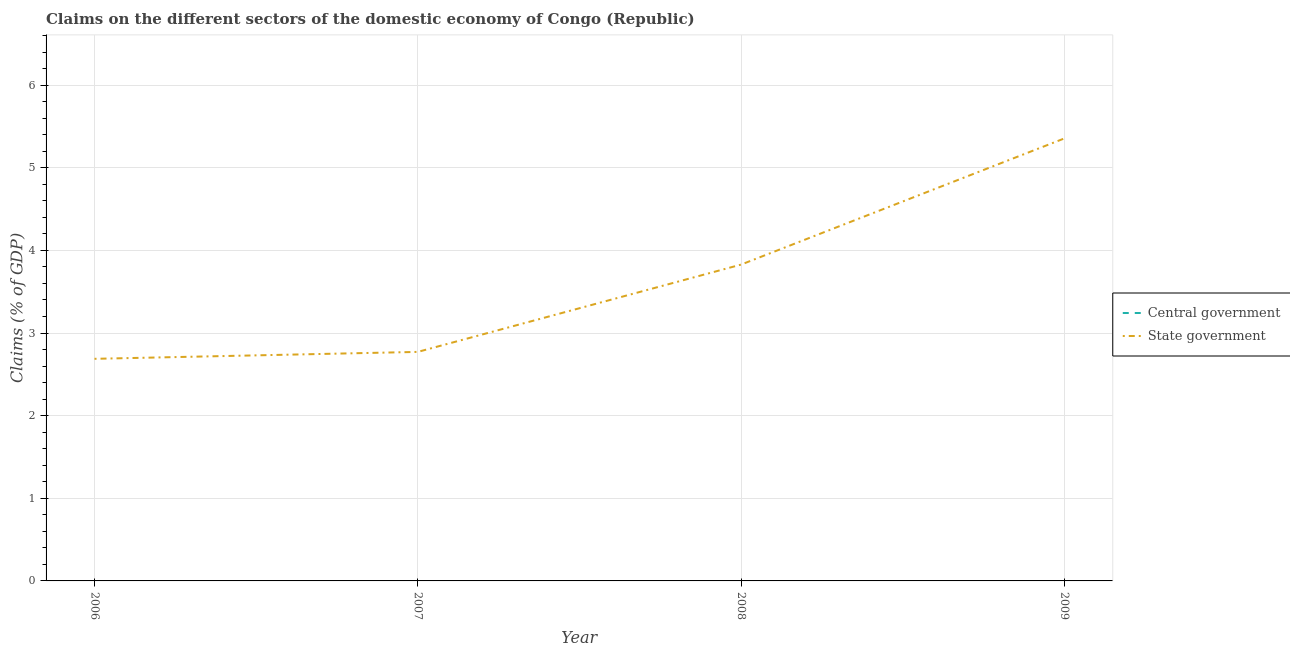How many different coloured lines are there?
Ensure brevity in your answer.  1. Does the line corresponding to claims on central government intersect with the line corresponding to claims on state government?
Offer a very short reply. No. Is the number of lines equal to the number of legend labels?
Provide a succinct answer. No. Across all years, what is the maximum claims on state government?
Provide a short and direct response. 5.35. Across all years, what is the minimum claims on state government?
Ensure brevity in your answer.  2.69. What is the total claims on state government in the graph?
Offer a very short reply. 14.64. What is the difference between the claims on state government in 2006 and that in 2009?
Your answer should be compact. -2.67. What is the difference between the claims on central government in 2009 and the claims on state government in 2007?
Your answer should be compact. -2.77. What is the average claims on central government per year?
Provide a short and direct response. 0. What is the ratio of the claims on state government in 2006 to that in 2008?
Your response must be concise. 0.7. What is the difference between the highest and the second highest claims on state government?
Offer a very short reply. 1.53. What is the difference between the highest and the lowest claims on state government?
Offer a very short reply. 2.67. In how many years, is the claims on central government greater than the average claims on central government taken over all years?
Your answer should be compact. 0. Is the sum of the claims on state government in 2007 and 2009 greater than the maximum claims on central government across all years?
Provide a succinct answer. Yes. Does the claims on central government monotonically increase over the years?
Give a very brief answer. No. How many lines are there?
Your answer should be compact. 1. Are the values on the major ticks of Y-axis written in scientific E-notation?
Keep it short and to the point. No. Does the graph contain any zero values?
Provide a succinct answer. Yes. Does the graph contain grids?
Give a very brief answer. Yes. How many legend labels are there?
Make the answer very short. 2. How are the legend labels stacked?
Provide a succinct answer. Vertical. What is the title of the graph?
Make the answer very short. Claims on the different sectors of the domestic economy of Congo (Republic). What is the label or title of the X-axis?
Offer a terse response. Year. What is the label or title of the Y-axis?
Provide a short and direct response. Claims (% of GDP). What is the Claims (% of GDP) in Central government in 2006?
Provide a succinct answer. 0. What is the Claims (% of GDP) in State government in 2006?
Your answer should be very brief. 2.69. What is the Claims (% of GDP) of Central government in 2007?
Give a very brief answer. 0. What is the Claims (% of GDP) of State government in 2007?
Make the answer very short. 2.77. What is the Claims (% of GDP) in Central government in 2008?
Offer a very short reply. 0. What is the Claims (% of GDP) in State government in 2008?
Offer a very short reply. 3.83. What is the Claims (% of GDP) in Central government in 2009?
Make the answer very short. 0. What is the Claims (% of GDP) in State government in 2009?
Keep it short and to the point. 5.35. Across all years, what is the maximum Claims (% of GDP) of State government?
Offer a very short reply. 5.35. Across all years, what is the minimum Claims (% of GDP) in State government?
Offer a very short reply. 2.69. What is the total Claims (% of GDP) of Central government in the graph?
Offer a terse response. 0. What is the total Claims (% of GDP) in State government in the graph?
Ensure brevity in your answer.  14.64. What is the difference between the Claims (% of GDP) of State government in 2006 and that in 2007?
Provide a succinct answer. -0.08. What is the difference between the Claims (% of GDP) of State government in 2006 and that in 2008?
Give a very brief answer. -1.14. What is the difference between the Claims (% of GDP) in State government in 2006 and that in 2009?
Offer a very short reply. -2.67. What is the difference between the Claims (% of GDP) of State government in 2007 and that in 2008?
Provide a short and direct response. -1.06. What is the difference between the Claims (% of GDP) in State government in 2007 and that in 2009?
Provide a succinct answer. -2.58. What is the difference between the Claims (% of GDP) in State government in 2008 and that in 2009?
Provide a short and direct response. -1.53. What is the average Claims (% of GDP) of Central government per year?
Your answer should be very brief. 0. What is the average Claims (% of GDP) of State government per year?
Offer a terse response. 3.66. What is the ratio of the Claims (% of GDP) in State government in 2006 to that in 2007?
Your answer should be very brief. 0.97. What is the ratio of the Claims (% of GDP) in State government in 2006 to that in 2008?
Provide a succinct answer. 0.7. What is the ratio of the Claims (% of GDP) of State government in 2006 to that in 2009?
Your response must be concise. 0.5. What is the ratio of the Claims (% of GDP) in State government in 2007 to that in 2008?
Your response must be concise. 0.72. What is the ratio of the Claims (% of GDP) of State government in 2007 to that in 2009?
Offer a very short reply. 0.52. What is the ratio of the Claims (% of GDP) of State government in 2008 to that in 2009?
Keep it short and to the point. 0.71. What is the difference between the highest and the second highest Claims (% of GDP) of State government?
Your response must be concise. 1.53. What is the difference between the highest and the lowest Claims (% of GDP) of State government?
Give a very brief answer. 2.67. 